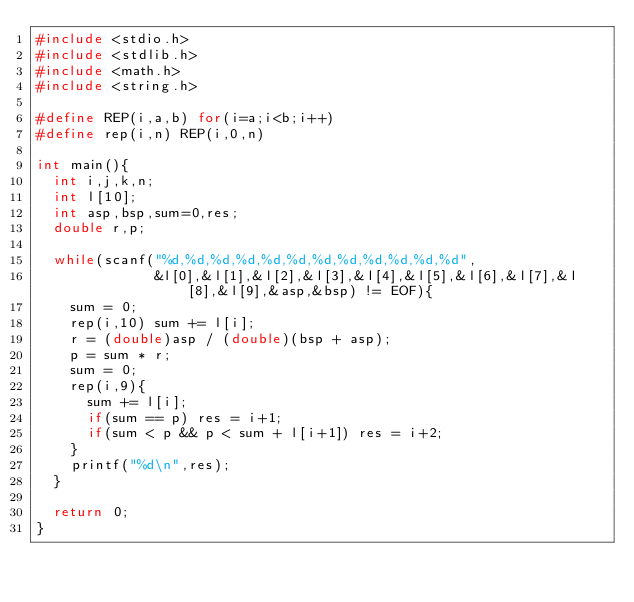Convert code to text. <code><loc_0><loc_0><loc_500><loc_500><_C_>#include <stdio.h>
#include <stdlib.h>
#include <math.h>
#include <string.h>

#define REP(i,a,b) for(i=a;i<b;i++)
#define rep(i,n) REP(i,0,n)

int main(){
  int i,j,k,n;
  int l[10];
  int asp,bsp,sum=0,res;
  double r,p;

  while(scanf("%d,%d,%d,%d,%d,%d,%d,%d,%d,%d,%d,%d",
              &l[0],&l[1],&l[2],&l[3],&l[4],&l[5],&l[6],&l[7],&l[8],&l[9],&asp,&bsp) != EOF){
    sum = 0;
    rep(i,10) sum += l[i];
    r = (double)asp / (double)(bsp + asp);
    p = sum * r;
    sum = 0;
    rep(i,9){
      sum += l[i];
      if(sum == p) res = i+1;
      if(sum < p && p < sum + l[i+1]) res = i+2;
    }
    printf("%d\n",res);
  }

  return 0;
}</code> 